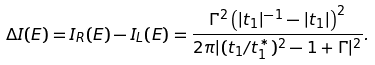<formula> <loc_0><loc_0><loc_500><loc_500>\Delta I ( E ) = I _ { R } ( E ) - I _ { L } ( E ) = \frac { \Gamma ^ { 2 } \left ( | t _ { 1 } | ^ { - 1 } - | t _ { 1 } | \right ) ^ { 2 } } { 2 \pi | ( t _ { 1 } / t _ { 1 } ^ { * } ) ^ { 2 } - 1 + \Gamma | ^ { 2 } } .</formula> 